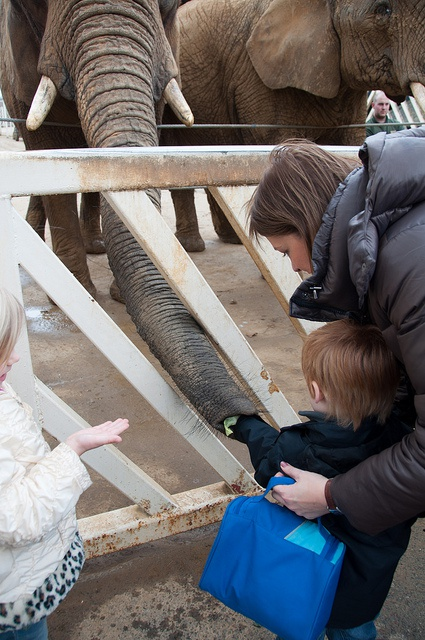Describe the objects in this image and their specific colors. I can see elephant in gray, black, and darkgray tones, people in gray, black, and darkgray tones, elephant in gray, black, and maroon tones, people in gray, black, maroon, and brown tones, and people in gray, lightgray, and darkgray tones in this image. 